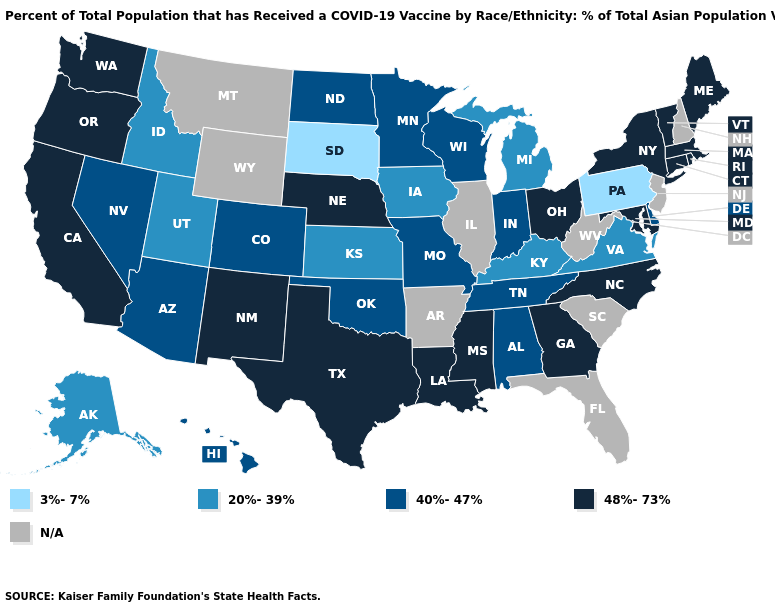Name the states that have a value in the range 48%-73%?
Short answer required. California, Connecticut, Georgia, Louisiana, Maine, Maryland, Massachusetts, Mississippi, Nebraska, New Mexico, New York, North Carolina, Ohio, Oregon, Rhode Island, Texas, Vermont, Washington. Does Virginia have the lowest value in the USA?
Write a very short answer. No. Name the states that have a value in the range N/A?
Concise answer only. Arkansas, Florida, Illinois, Montana, New Hampshire, New Jersey, South Carolina, West Virginia, Wyoming. What is the value of California?
Keep it brief. 48%-73%. What is the lowest value in the USA?
Quick response, please. 3%-7%. Does New York have the highest value in the USA?
Give a very brief answer. Yes. What is the lowest value in the USA?
Concise answer only. 3%-7%. Which states have the lowest value in the USA?
Short answer required. Pennsylvania, South Dakota. Does Kentucky have the highest value in the USA?
Concise answer only. No. What is the value of Iowa?
Keep it brief. 20%-39%. Does the map have missing data?
Answer briefly. Yes. Name the states that have a value in the range 40%-47%?
Keep it brief. Alabama, Arizona, Colorado, Delaware, Hawaii, Indiana, Minnesota, Missouri, Nevada, North Dakota, Oklahoma, Tennessee, Wisconsin. What is the value of North Dakota?
Answer briefly. 40%-47%. What is the highest value in the South ?
Be succinct. 48%-73%. 